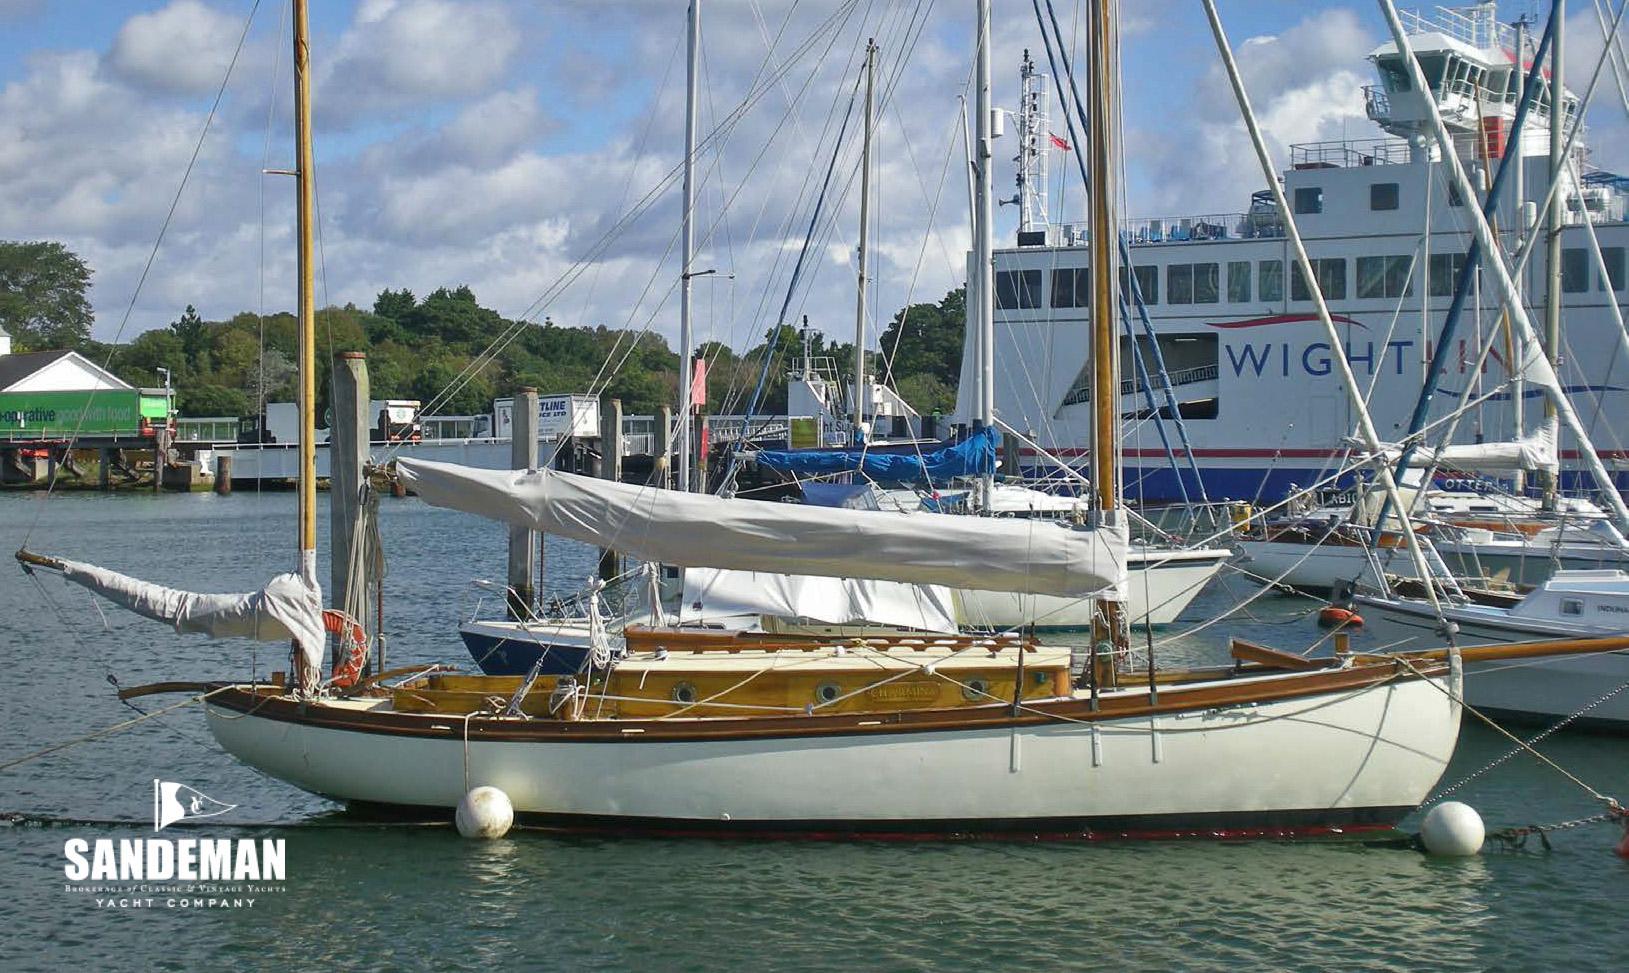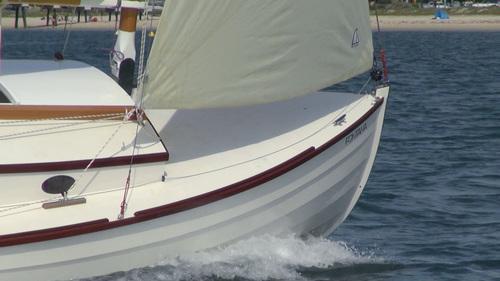The first image is the image on the left, the second image is the image on the right. Assess this claim about the two images: "The sails in the left image are closed.". Correct or not? Answer yes or no. Yes. 